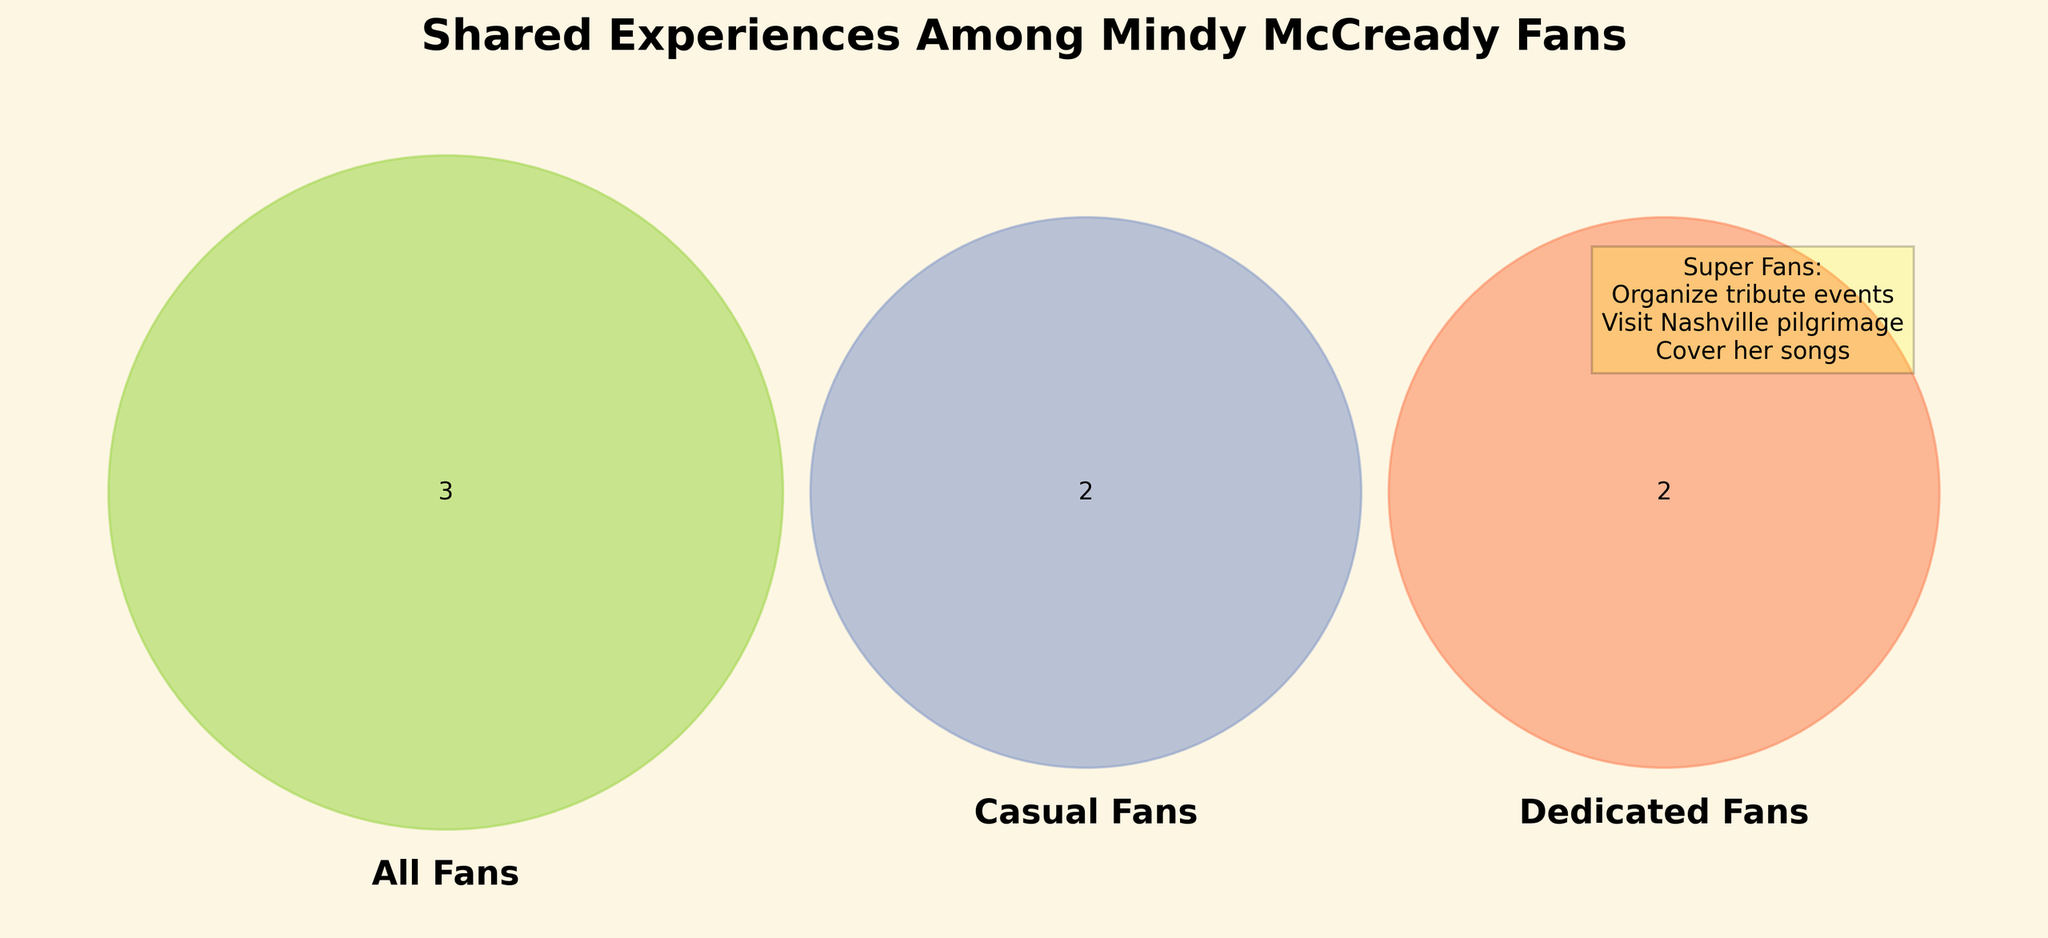What's the title of the figure? The title is prominently displayed at the top of the figure.
Answer: Shared Experiences Among Mindy McCready Fans Which fan group has the highest number of unique experiences listed? By looking at the Venn diagram and the text box for Super Fans, we see that Super Fans have the most unique experiences listed on the side.
Answer: Super Fans What experience is unique to Casual Fans and not shared with any other group? Casual Fans have two unique experiences. We need to identify the one not overlapping with All Fans or Dedicated Fans.
Answer: Follow on social media How many experiences do all fans (All Fans, Casual Fans, Dedicated Fans) share? By identifying the overlapping section in the middle of the Venn diagram where All Fans intersect with both Casual Fans and Dedicated Fans.
Answer: 3 Is "Organize tribute events" an experience exclusive to Super Fans? The text box for Super Fans lists "Organize tribute events," and it does not overlap with any other group in the Venn diagram.
Answer: Yes What is one shared experience between Casual Fans and Dedicated Fans but not shared with All Fans? We look for an overlap between Casual Fans and Dedicated Fans that does not intersect with All Fans.
Answer: Collect memorabilia Do Super Fans also engage in activities listed under All Fans? Super Fans' unique experiences are in a separate list, not directly represented in the Venn sections shared by All Fans.
Answer: No Which fan category covers "Participate in fan clubs"? The segment in the Venn diagram marked for Dedicated Fans includes "Participate in fan clubs."
Answer: Dedicated Fans What shared experience do Casual Fans and All Fans have in common that Dedicated Fans do not? The area of the Venn diagram where Casual Fans and All Fans overlap but do not intersect with Dedicated Fans holds this information.
Answer: Stream music 